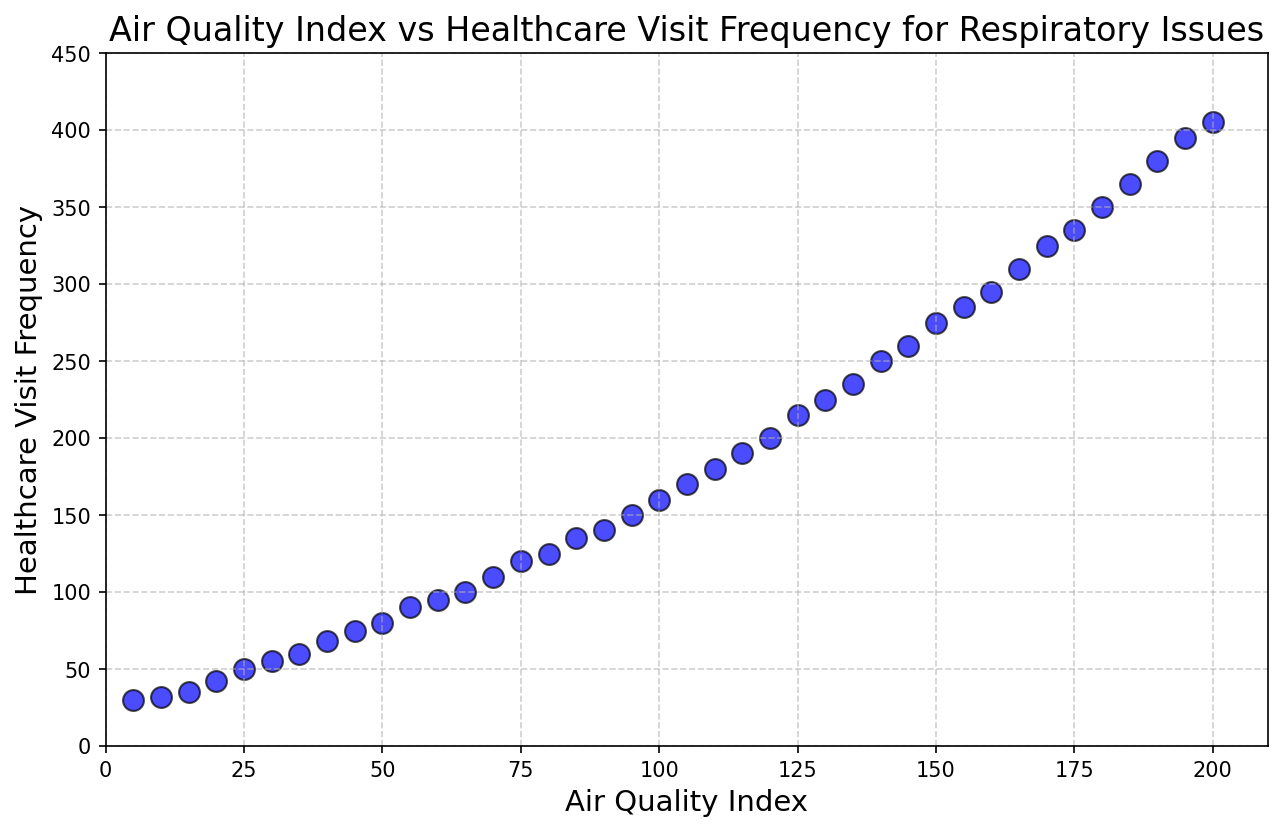What's the highest Air Quality Index value shown in the plot? The plot shows the Air Quality Index values on the x-axis. The highest point on the x-axis is 200.
Answer: 200 How does the frequency of healthcare visits change as the Air Quality Index increases? Observing the scatter plot, there is a general upward trend in healthcare visit frequency as the Air Quality Index increases, indicating a positive correlation.
Answer: Increases What's the difference in Healthcare Visit Frequency between an Air Quality Index of 50 and 100? For an Air Quality Index of 50, the Healthcare Visit Frequency is 80. For an Index of 100, it is 160. The difference is 160 - 80.
Answer: 80 What is the average Healthcare Visit Frequency for Air Quality Index values of 50, 100, and 150? Healthcare Visit Frequencies for AQI values of 50, 100, and 150 are 80, 160, and 275. The sum is 80 + 160 + 275 = 515. The average is 515 / 3.
Answer: 171.67 Compare Healthcare Visit Frequencies for Air Quality Index values of 75 and 125. Which is higher? At an Air Quality Index of 75, the frequency is 120. At an Index of 125, it is 215. Since 215 > 120, the frequency is higher at an Index of 125.
Answer: Air Quality Index of 125 Which Air Quality Index value corresponds to a Healthcare Visit Frequency of 295? The plot shows a point where the Healthcare Visit Frequency is 295, corresponding to an Air Quality Index of 160.
Answer: 160 Describe the visual appearance of the data points in the plot. The plot shows blue circular markers with a black edge scattered across the graph. The markers are semi-transparent and uniformly sized.
Answer: Blue circles with black edges By how much does the Healthcare Visit Frequency increase on average for each 10-point increase in Air Quality Index? Take two distant points, like from AQI 50 (frequency 80) to AQI 200 (frequency 405). The total increase in visits is 405 - 80 = 325, and the AQI increase is 200 - 50 = 150. Average increase is 325 / (150 / 10).
Answer: Approximately 21.67 At what Air Quality Index does the Healthcare Visit Frequency first exceed 100? Looking at the plot, Healthcare Visit Frequency exceeds 100 at an Air Quality Index value of 65.
Answer: 65 